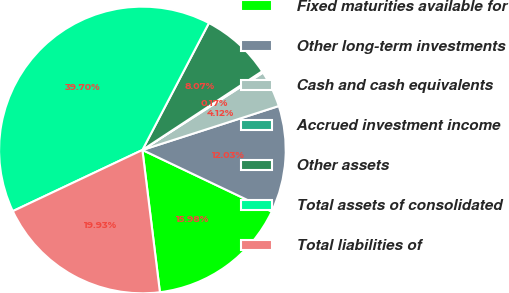Convert chart to OTSL. <chart><loc_0><loc_0><loc_500><loc_500><pie_chart><fcel>Fixed maturities available for<fcel>Other long-term investments<fcel>Cash and cash equivalents<fcel>Accrued investment income<fcel>Other assets<fcel>Total assets of consolidated<fcel>Total liabilities of<nl><fcel>15.98%<fcel>12.03%<fcel>4.12%<fcel>0.17%<fcel>8.07%<fcel>39.7%<fcel>19.93%<nl></chart> 